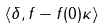Convert formula to latex. <formula><loc_0><loc_0><loc_500><loc_500>\langle \delta , f - f ( 0 ) \kappa \rangle</formula> 